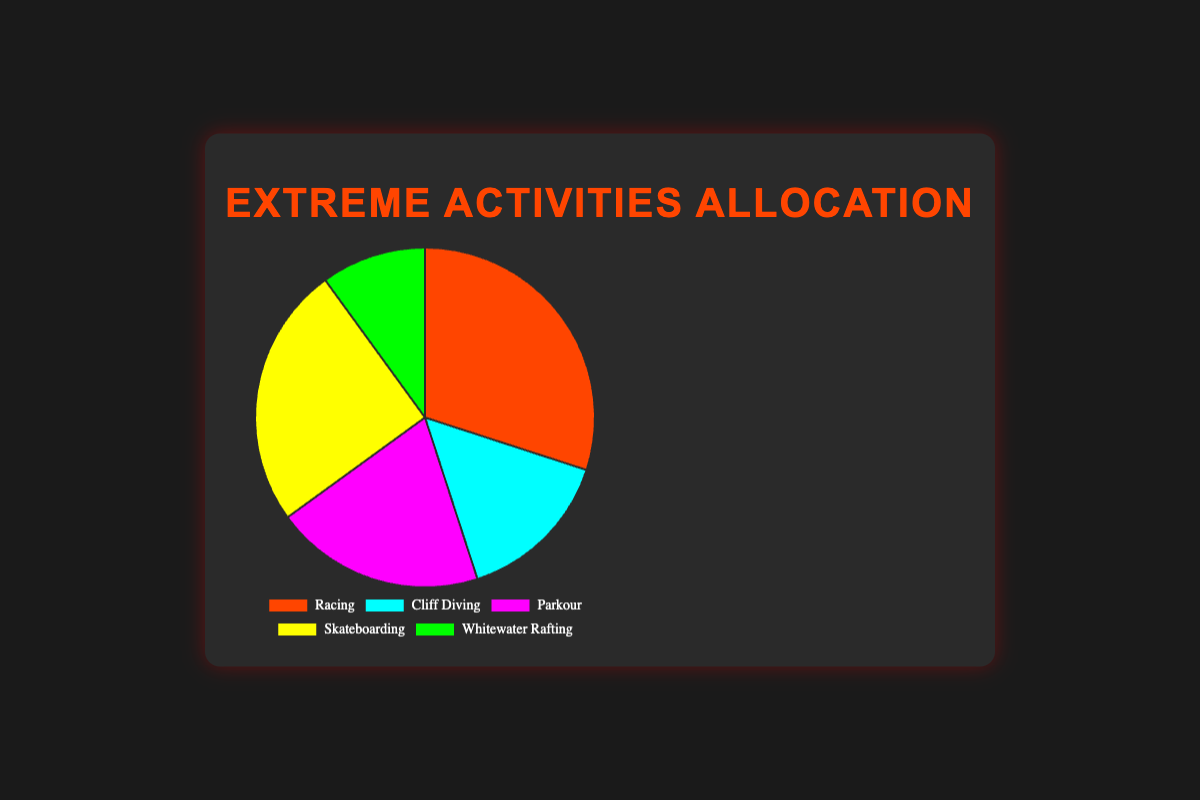What percentage of time is spent on parkour? The pie chart shows the times spent on different high-adrenaline activities with Parkour labeled as 20%.
Answer: 20% Which activity takes up the most time? By looking at the individual segments, Racing has the largest segment at 30%.
Answer: Racing How much more time is spent on skateboarding than on whitewater rafting? Skateboarding takes 25% and whitewater rafting takes 10%. The difference is 25% - 10% = 15%.
Answer: 15% What's the total percentage of time spent on racing and cliff diving together? Add the percentages for Racing and Cliff Diving: 30% + 15% = 45%.
Answer: 45% Which two activities combined make up exactly half of the entire time allocation? The pie chart shows that Parkour and Skateboarding are both 20% and 25% respectively, totaling 20% + 25% = 45%, not 50%. But Racing at 30% + Whitewater Rafting at 10% makes 40%, still not 50%. Only Racing 30% + Skateboarding 25% equals 55%. None fit 50%.
Answer: None If you spent equal time on cliff diving and whitewater rafting, what would their combined percentage be? Both Cliff Diving and Whitewater Rafting percentages need adding: 15% + 10% = 25%.
Answer: 25% Which activity represents the smallest proportion of time? Whitewater Rafting is marked as 10%, the smallest in the figure.
Answer: Whitewater Rafting Which activity is depicted in blue? By identifying the colors associated with each activity, Parkour corresponds to the blue segment.
Answer: Parkour How much more time is spent on racing compared to parkour? Racing has 30% and Parkour has 20%. The difference is 30% - 20% = 10%.
Answer: 10% If you were to spend the same amount of time on cliff diving and parkour, would that be more or less than racing? The combined time for Cliff Diving and Parkour is 15% + 20% = 35%, which is more than the 30% for Racing.
Answer: More 